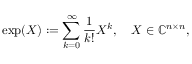<formula> <loc_0><loc_0><loc_500><loc_500>\exp ( X ) \colon = \sum _ { k = 0 } ^ { \infty } { \frac { 1 } { k ! } } X ^ { k } , \quad X \in \mathbb { C } ^ { n \times n } ,</formula> 